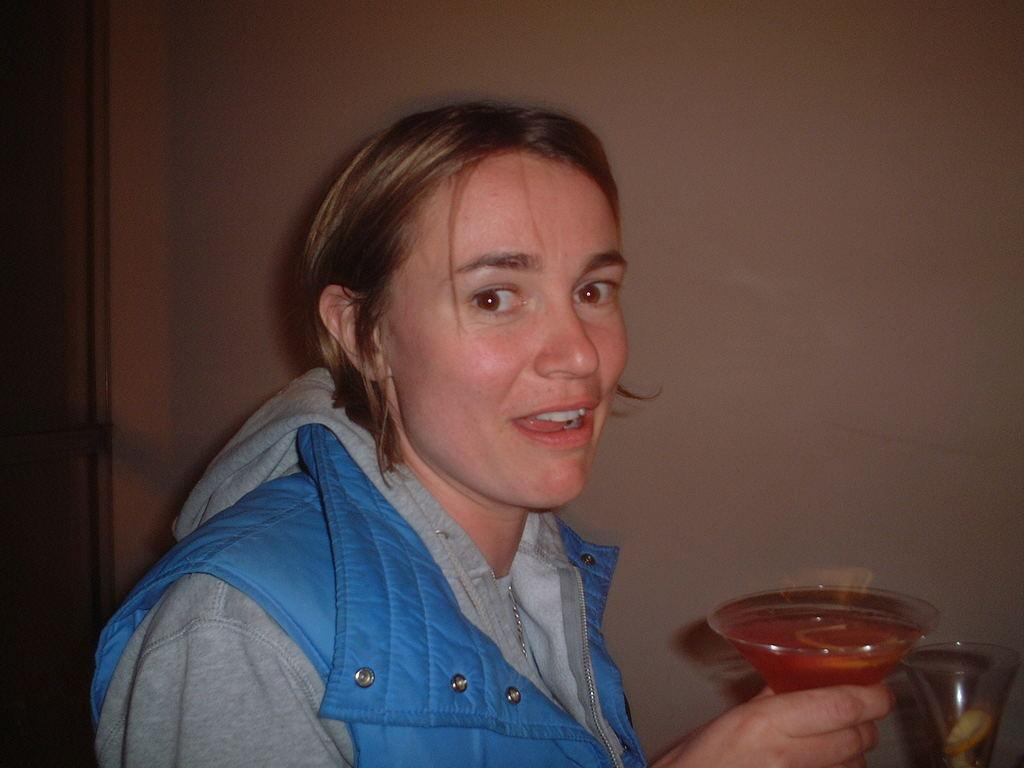Who is present in the image? There is a woman in the image. What is the woman holding in her hand? The woman is holding a glass. What is inside the glass? There is a drink in the glass. What type of gun can be seen in the woman's hand in the image? There is no gun present in the image; the woman is holding a glass. What time of day is it in the image, considering the presence of a stick? There is no stick present in the image, and therefore the time of day cannot be determined based on this object. 